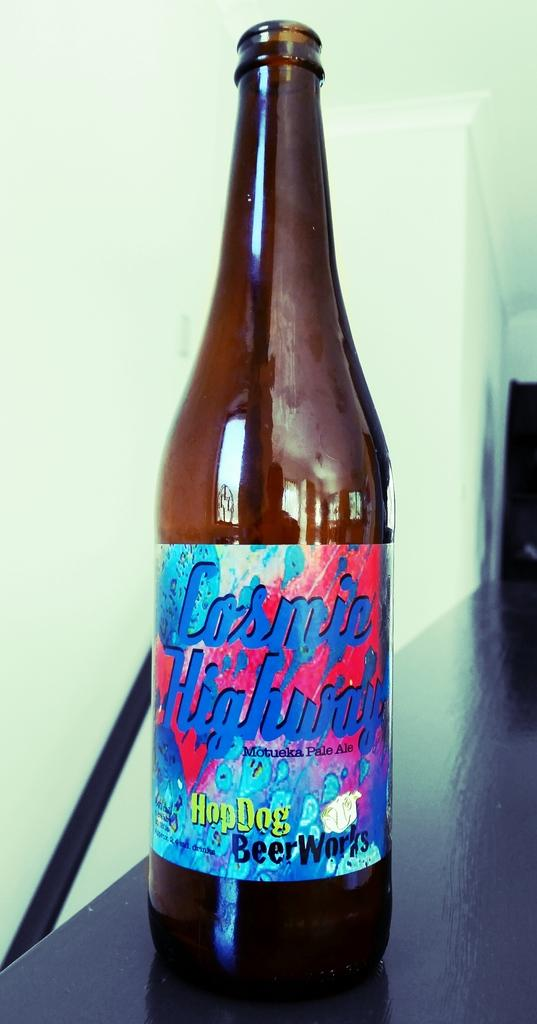<image>
Render a clear and concise summary of the photo. A bottle of Cosmic Highway Hop Dog beer stands open on a counter. 